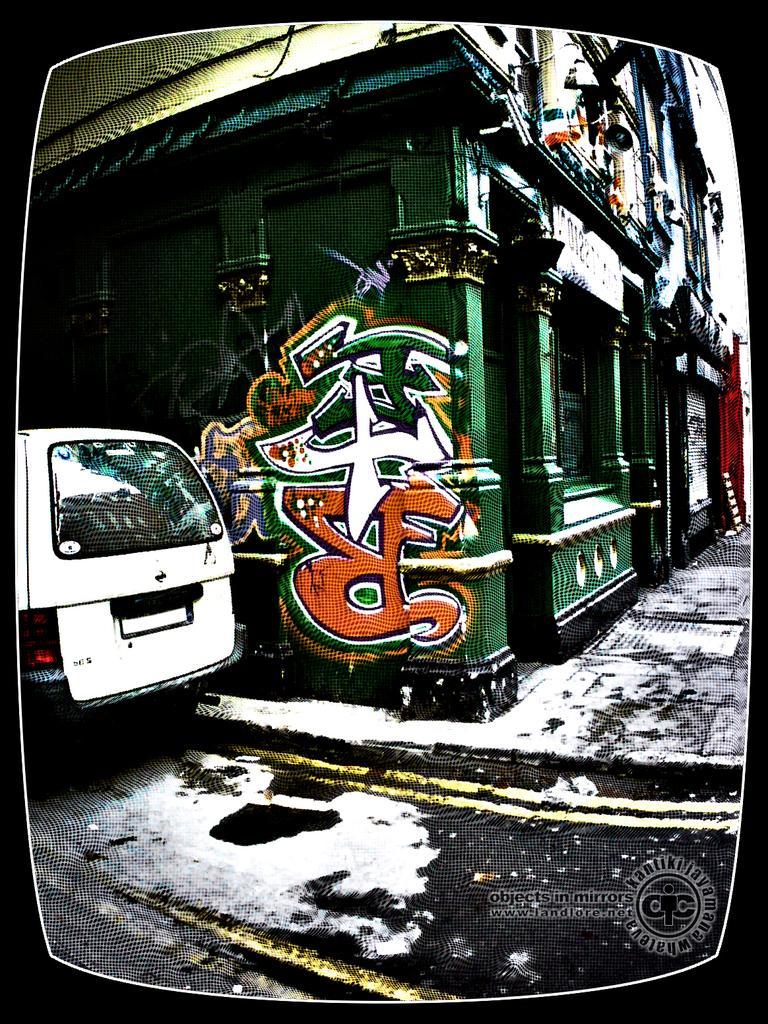How would you summarize this image in a sentence or two? In this picture we can see a vehicle on the road, footpath, building with windows and a painting on it. 